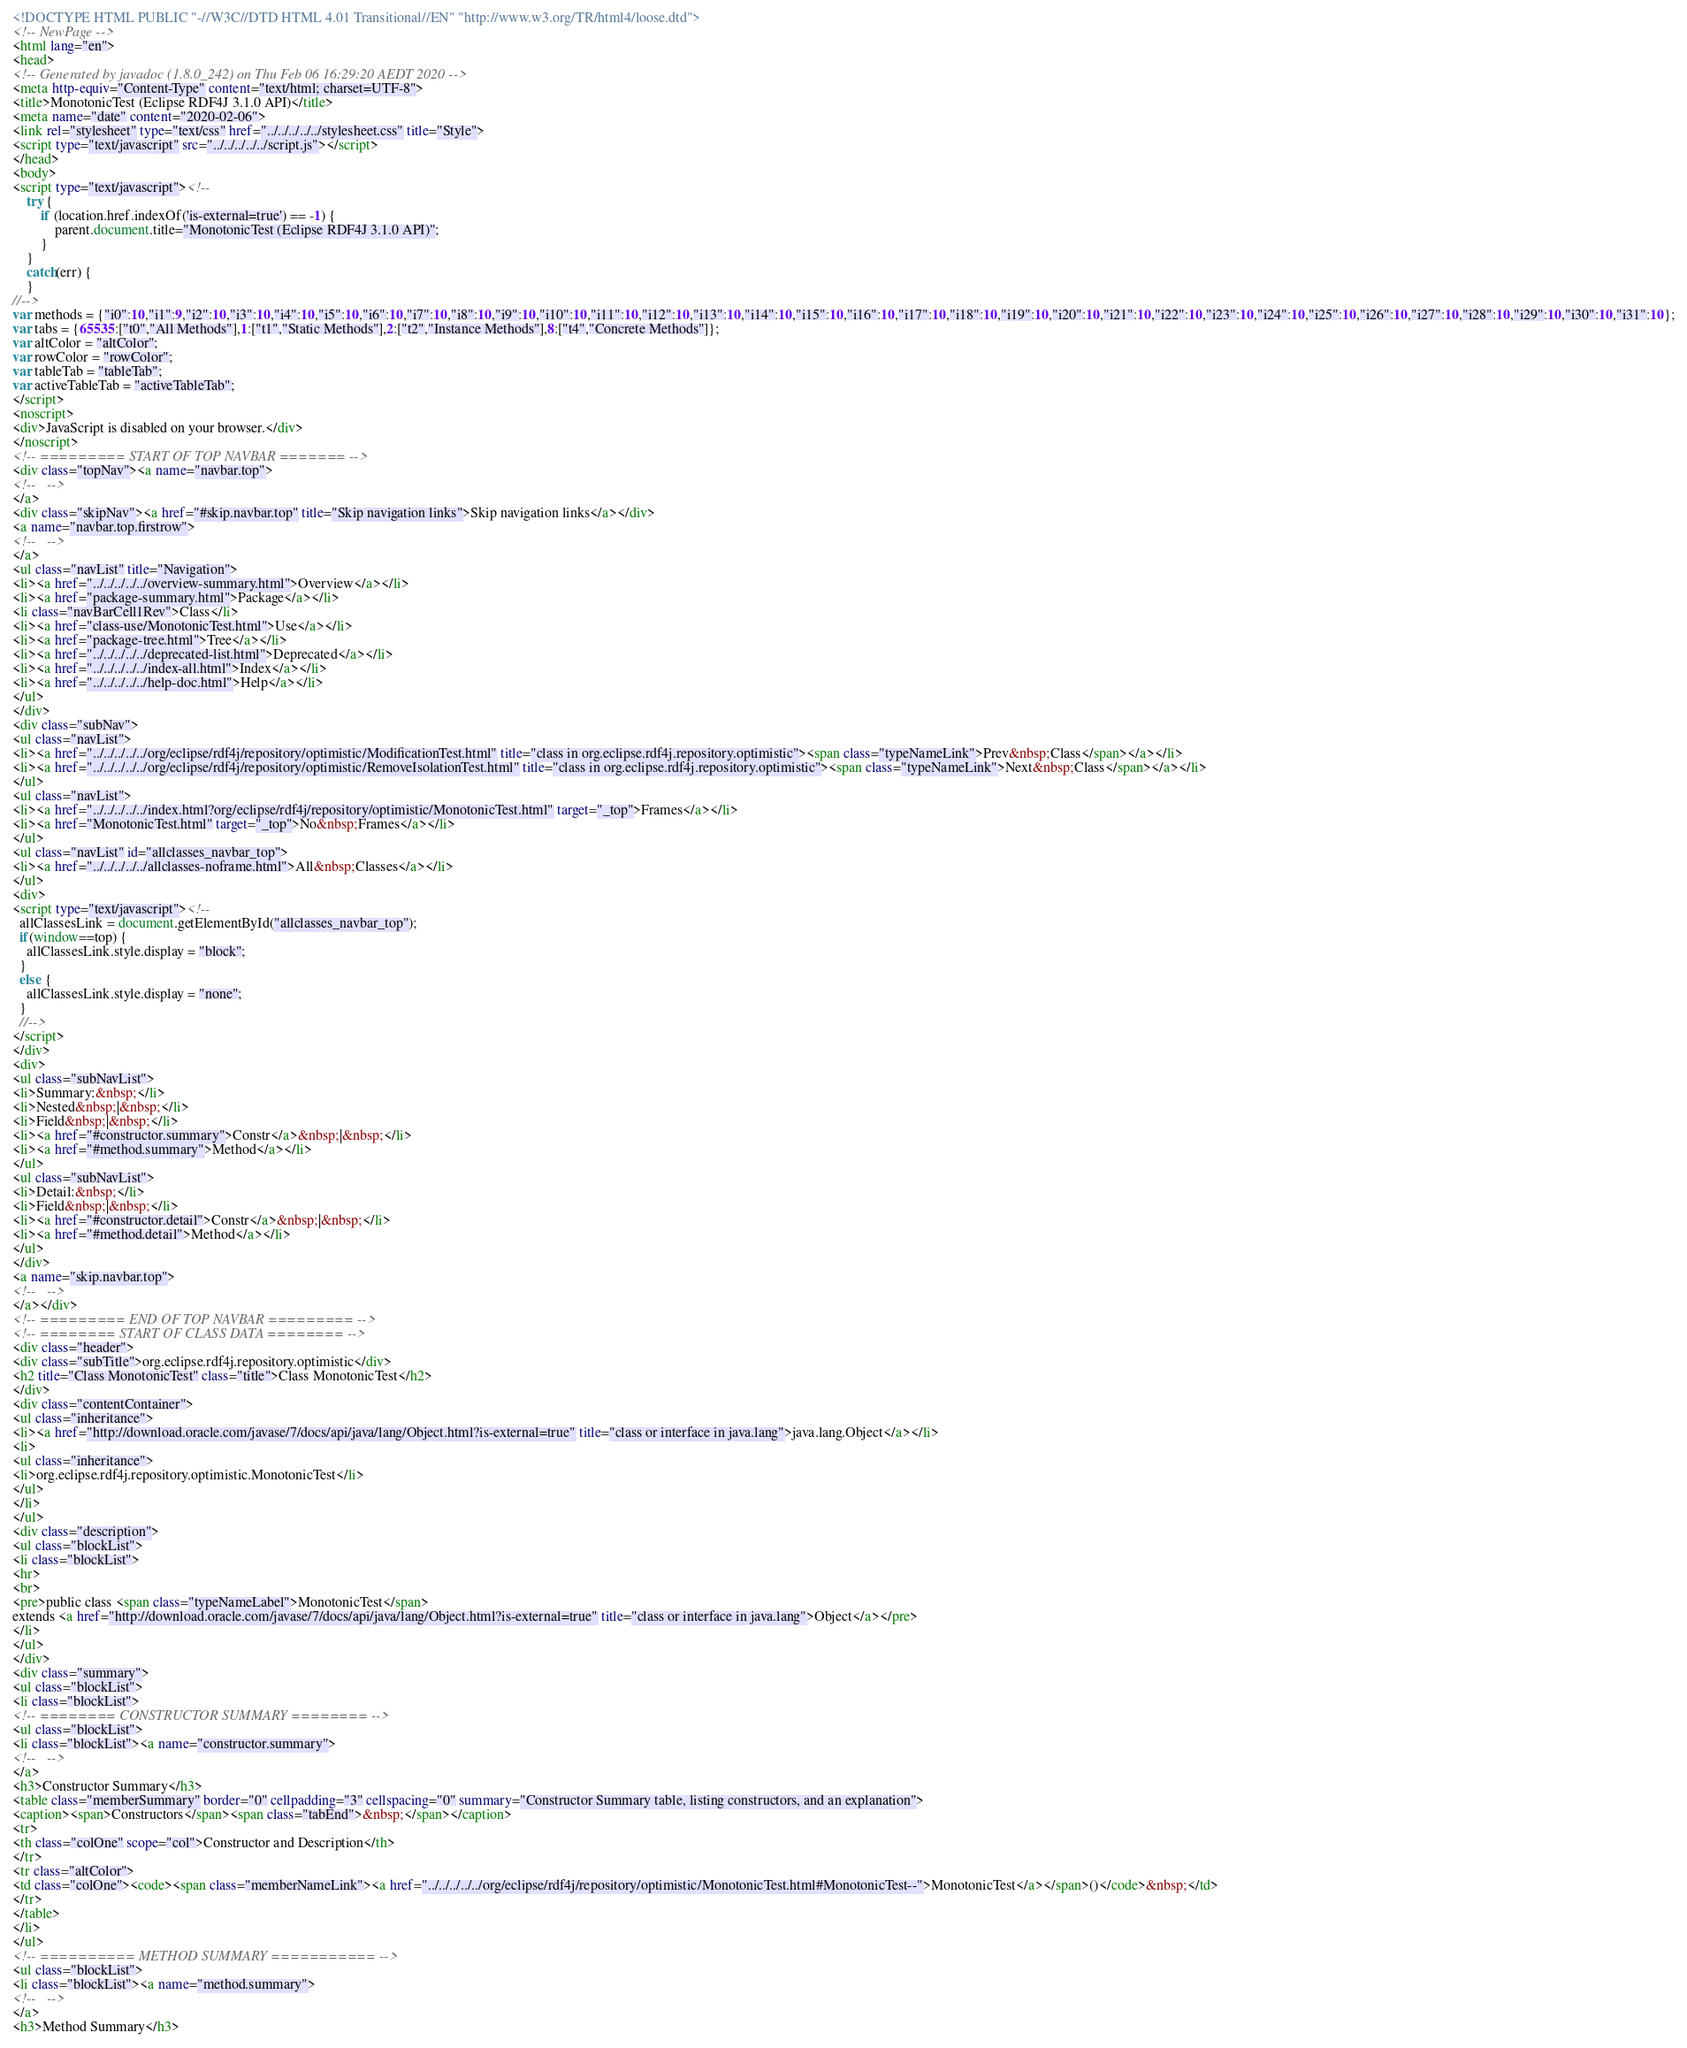<code> <loc_0><loc_0><loc_500><loc_500><_HTML_><!DOCTYPE HTML PUBLIC "-//W3C//DTD HTML 4.01 Transitional//EN" "http://www.w3.org/TR/html4/loose.dtd">
<!-- NewPage -->
<html lang="en">
<head>
<!-- Generated by javadoc (1.8.0_242) on Thu Feb 06 16:29:20 AEDT 2020 -->
<meta http-equiv="Content-Type" content="text/html; charset=UTF-8">
<title>MonotonicTest (Eclipse RDF4J 3.1.0 API)</title>
<meta name="date" content="2020-02-06">
<link rel="stylesheet" type="text/css" href="../../../../../stylesheet.css" title="Style">
<script type="text/javascript" src="../../../../../script.js"></script>
</head>
<body>
<script type="text/javascript"><!--
    try {
        if (location.href.indexOf('is-external=true') == -1) {
            parent.document.title="MonotonicTest (Eclipse RDF4J 3.1.0 API)";
        }
    }
    catch(err) {
    }
//-->
var methods = {"i0":10,"i1":9,"i2":10,"i3":10,"i4":10,"i5":10,"i6":10,"i7":10,"i8":10,"i9":10,"i10":10,"i11":10,"i12":10,"i13":10,"i14":10,"i15":10,"i16":10,"i17":10,"i18":10,"i19":10,"i20":10,"i21":10,"i22":10,"i23":10,"i24":10,"i25":10,"i26":10,"i27":10,"i28":10,"i29":10,"i30":10,"i31":10};
var tabs = {65535:["t0","All Methods"],1:["t1","Static Methods"],2:["t2","Instance Methods"],8:["t4","Concrete Methods"]};
var altColor = "altColor";
var rowColor = "rowColor";
var tableTab = "tableTab";
var activeTableTab = "activeTableTab";
</script>
<noscript>
<div>JavaScript is disabled on your browser.</div>
</noscript>
<!-- ========= START OF TOP NAVBAR ======= -->
<div class="topNav"><a name="navbar.top">
<!--   -->
</a>
<div class="skipNav"><a href="#skip.navbar.top" title="Skip navigation links">Skip navigation links</a></div>
<a name="navbar.top.firstrow">
<!--   -->
</a>
<ul class="navList" title="Navigation">
<li><a href="../../../../../overview-summary.html">Overview</a></li>
<li><a href="package-summary.html">Package</a></li>
<li class="navBarCell1Rev">Class</li>
<li><a href="class-use/MonotonicTest.html">Use</a></li>
<li><a href="package-tree.html">Tree</a></li>
<li><a href="../../../../../deprecated-list.html">Deprecated</a></li>
<li><a href="../../../../../index-all.html">Index</a></li>
<li><a href="../../../../../help-doc.html">Help</a></li>
</ul>
</div>
<div class="subNav">
<ul class="navList">
<li><a href="../../../../../org/eclipse/rdf4j/repository/optimistic/ModificationTest.html" title="class in org.eclipse.rdf4j.repository.optimistic"><span class="typeNameLink">Prev&nbsp;Class</span></a></li>
<li><a href="../../../../../org/eclipse/rdf4j/repository/optimistic/RemoveIsolationTest.html" title="class in org.eclipse.rdf4j.repository.optimistic"><span class="typeNameLink">Next&nbsp;Class</span></a></li>
</ul>
<ul class="navList">
<li><a href="../../../../../index.html?org/eclipse/rdf4j/repository/optimistic/MonotonicTest.html" target="_top">Frames</a></li>
<li><a href="MonotonicTest.html" target="_top">No&nbsp;Frames</a></li>
</ul>
<ul class="navList" id="allclasses_navbar_top">
<li><a href="../../../../../allclasses-noframe.html">All&nbsp;Classes</a></li>
</ul>
<div>
<script type="text/javascript"><!--
  allClassesLink = document.getElementById("allclasses_navbar_top");
  if(window==top) {
    allClassesLink.style.display = "block";
  }
  else {
    allClassesLink.style.display = "none";
  }
  //-->
</script>
</div>
<div>
<ul class="subNavList">
<li>Summary:&nbsp;</li>
<li>Nested&nbsp;|&nbsp;</li>
<li>Field&nbsp;|&nbsp;</li>
<li><a href="#constructor.summary">Constr</a>&nbsp;|&nbsp;</li>
<li><a href="#method.summary">Method</a></li>
</ul>
<ul class="subNavList">
<li>Detail:&nbsp;</li>
<li>Field&nbsp;|&nbsp;</li>
<li><a href="#constructor.detail">Constr</a>&nbsp;|&nbsp;</li>
<li><a href="#method.detail">Method</a></li>
</ul>
</div>
<a name="skip.navbar.top">
<!--   -->
</a></div>
<!-- ========= END OF TOP NAVBAR ========= -->
<!-- ======== START OF CLASS DATA ======== -->
<div class="header">
<div class="subTitle">org.eclipse.rdf4j.repository.optimistic</div>
<h2 title="Class MonotonicTest" class="title">Class MonotonicTest</h2>
</div>
<div class="contentContainer">
<ul class="inheritance">
<li><a href="http://download.oracle.com/javase/7/docs/api/java/lang/Object.html?is-external=true" title="class or interface in java.lang">java.lang.Object</a></li>
<li>
<ul class="inheritance">
<li>org.eclipse.rdf4j.repository.optimistic.MonotonicTest</li>
</ul>
</li>
</ul>
<div class="description">
<ul class="blockList">
<li class="blockList">
<hr>
<br>
<pre>public class <span class="typeNameLabel">MonotonicTest</span>
extends <a href="http://download.oracle.com/javase/7/docs/api/java/lang/Object.html?is-external=true" title="class or interface in java.lang">Object</a></pre>
</li>
</ul>
</div>
<div class="summary">
<ul class="blockList">
<li class="blockList">
<!-- ======== CONSTRUCTOR SUMMARY ======== -->
<ul class="blockList">
<li class="blockList"><a name="constructor.summary">
<!--   -->
</a>
<h3>Constructor Summary</h3>
<table class="memberSummary" border="0" cellpadding="3" cellspacing="0" summary="Constructor Summary table, listing constructors, and an explanation">
<caption><span>Constructors</span><span class="tabEnd">&nbsp;</span></caption>
<tr>
<th class="colOne" scope="col">Constructor and Description</th>
</tr>
<tr class="altColor">
<td class="colOne"><code><span class="memberNameLink"><a href="../../../../../org/eclipse/rdf4j/repository/optimistic/MonotonicTest.html#MonotonicTest--">MonotonicTest</a></span>()</code>&nbsp;</td>
</tr>
</table>
</li>
</ul>
<!-- ========== METHOD SUMMARY =========== -->
<ul class="blockList">
<li class="blockList"><a name="method.summary">
<!--   -->
</a>
<h3>Method Summary</h3></code> 